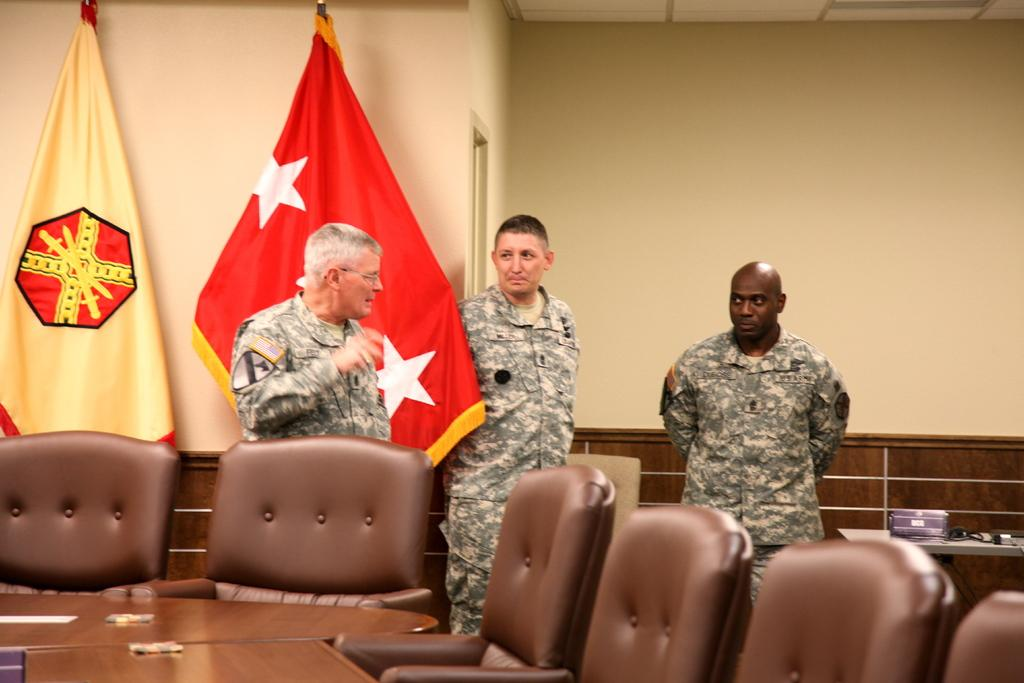How many people are in the image? There are three persons in the image. What are the persons doing in the image? The persons are standing. What can be seen in the background of the image? There is a flag, a wall, and a door in the background of the image. What type of sign is the grandmother holding in the image? There is no grandmother or sign present in the image. 